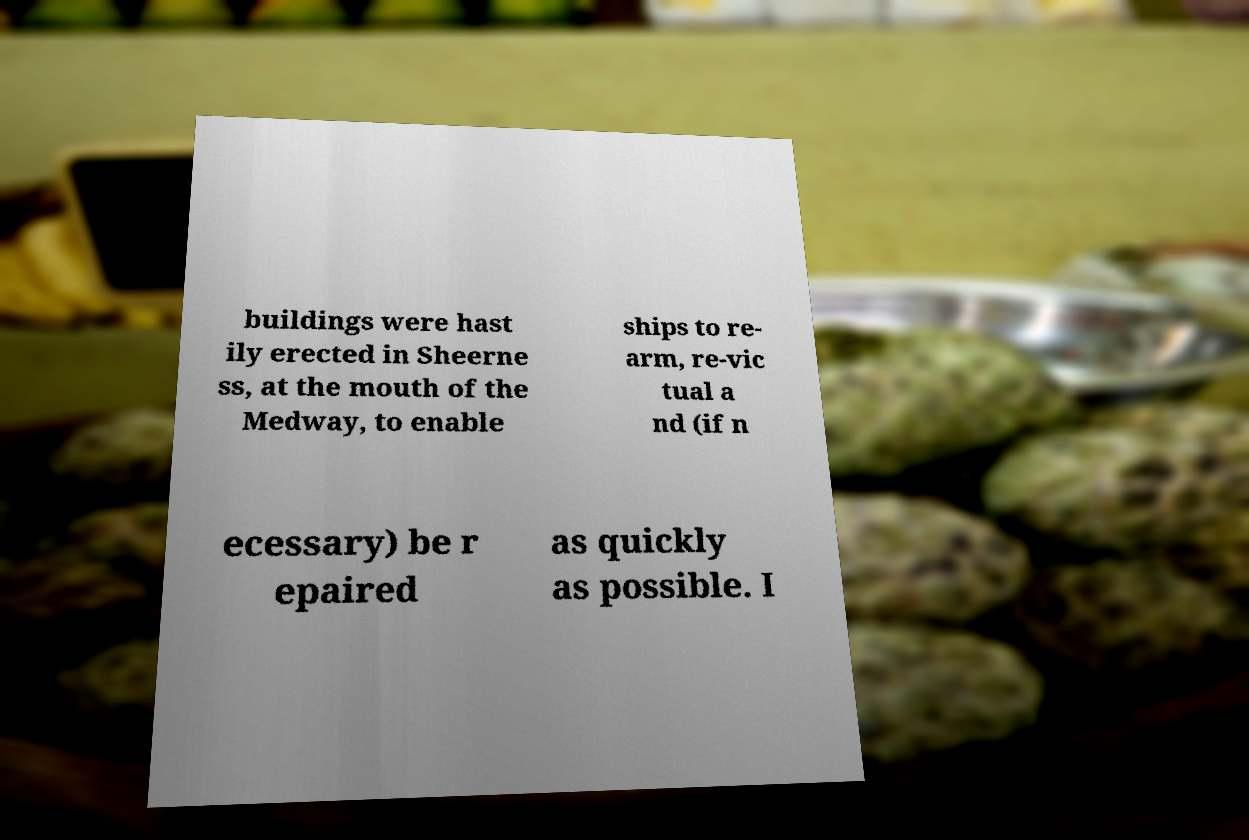Please identify and transcribe the text found in this image. buildings were hast ily erected in Sheerne ss, at the mouth of the Medway, to enable ships to re- arm, re-vic tual a nd (if n ecessary) be r epaired as quickly as possible. I 